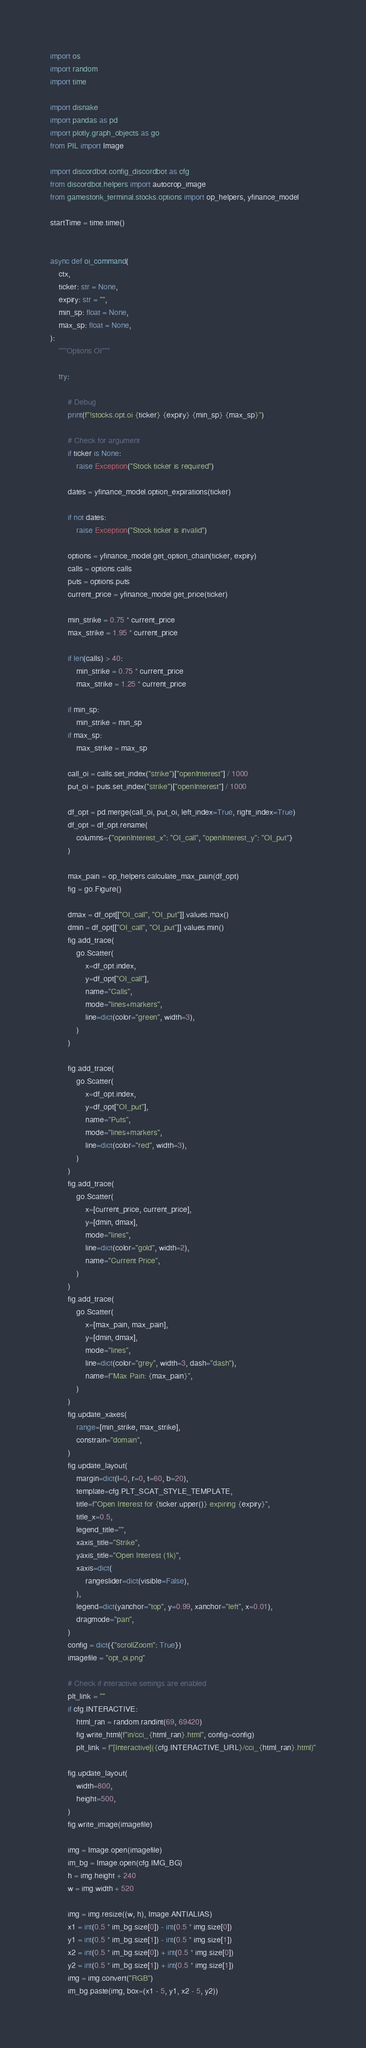<code> <loc_0><loc_0><loc_500><loc_500><_Python_>import os
import random
import time

import disnake
import pandas as pd
import plotly.graph_objects as go
from PIL import Image

import discordbot.config_discordbot as cfg
from discordbot.helpers import autocrop_image
from gamestonk_terminal.stocks.options import op_helpers, yfinance_model

startTime = time.time()


async def oi_command(
    ctx,
    ticker: str = None,
    expiry: str = "",
    min_sp: float = None,
    max_sp: float = None,
):
    """Options OI"""

    try:

        # Debug
        print(f"!stocks.opt.oi {ticker} {expiry} {min_sp} {max_sp}")

        # Check for argument
        if ticker is None:
            raise Exception("Stock ticker is required")

        dates = yfinance_model.option_expirations(ticker)

        if not dates:
            raise Exception("Stock ticker is invalid")

        options = yfinance_model.get_option_chain(ticker, expiry)
        calls = options.calls
        puts = options.puts
        current_price = yfinance_model.get_price(ticker)

        min_strike = 0.75 * current_price
        max_strike = 1.95 * current_price

        if len(calls) > 40:
            min_strike = 0.75 * current_price
            max_strike = 1.25 * current_price

        if min_sp:
            min_strike = min_sp
        if max_sp:
            max_strike = max_sp

        call_oi = calls.set_index("strike")["openInterest"] / 1000
        put_oi = puts.set_index("strike")["openInterest"] / 1000

        df_opt = pd.merge(call_oi, put_oi, left_index=True, right_index=True)
        df_opt = df_opt.rename(
            columns={"openInterest_x": "OI_call", "openInterest_y": "OI_put"}
        )

        max_pain = op_helpers.calculate_max_pain(df_opt)
        fig = go.Figure()

        dmax = df_opt[["OI_call", "OI_put"]].values.max()
        dmin = df_opt[["OI_call", "OI_put"]].values.min()
        fig.add_trace(
            go.Scatter(
                x=df_opt.index,
                y=df_opt["OI_call"],
                name="Calls",
                mode="lines+markers",
                line=dict(color="green", width=3),
            )
        )

        fig.add_trace(
            go.Scatter(
                x=df_opt.index,
                y=df_opt["OI_put"],
                name="Puts",
                mode="lines+markers",
                line=dict(color="red", width=3),
            )
        )
        fig.add_trace(
            go.Scatter(
                x=[current_price, current_price],
                y=[dmin, dmax],
                mode="lines",
                line=dict(color="gold", width=2),
                name="Current Price",
            )
        )
        fig.add_trace(
            go.Scatter(
                x=[max_pain, max_pain],
                y=[dmin, dmax],
                mode="lines",
                line=dict(color="grey", width=3, dash="dash"),
                name=f"Max Pain: {max_pain}",
            )
        )
        fig.update_xaxes(
            range=[min_strike, max_strike],
            constrain="domain",
        )
        fig.update_layout(
            margin=dict(l=0, r=0, t=60, b=20),
            template=cfg.PLT_SCAT_STYLE_TEMPLATE,
            title=f"Open Interest for {ticker.upper()} expiring {expiry}",
            title_x=0.5,
            legend_title="",
            xaxis_title="Strike",
            yaxis_title="Open Interest (1k)",
            xaxis=dict(
                rangeslider=dict(visible=False),
            ),
            legend=dict(yanchor="top", y=0.99, xanchor="left", x=0.01),
            dragmode="pan",
        )
        config = dict({"scrollZoom": True})
        imagefile = "opt_oi.png"

        # Check if interactive settings are enabled
        plt_link = ""
        if cfg.INTERACTIVE:
            html_ran = random.randint(69, 69420)
            fig.write_html(f"in/cci_{html_ran}.html", config=config)
            plt_link = f"[Interactive]({cfg.INTERACTIVE_URL}/cci_{html_ran}.html)"

        fig.update_layout(
            width=800,
            height=500,
        )
        fig.write_image(imagefile)

        img = Image.open(imagefile)
        im_bg = Image.open(cfg.IMG_BG)
        h = img.height + 240
        w = img.width + 520

        img = img.resize((w, h), Image.ANTIALIAS)
        x1 = int(0.5 * im_bg.size[0]) - int(0.5 * img.size[0])
        y1 = int(0.5 * im_bg.size[1]) - int(0.5 * img.size[1])
        x2 = int(0.5 * im_bg.size[0]) + int(0.5 * img.size[0])
        y2 = int(0.5 * im_bg.size[1]) + int(0.5 * img.size[1])
        img = img.convert("RGB")
        im_bg.paste(img, box=(x1 - 5, y1, x2 - 5, y2))</code> 